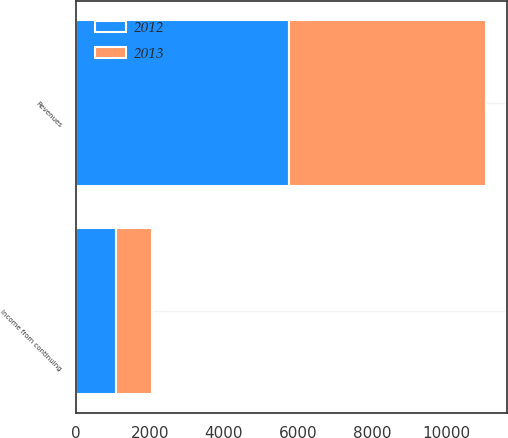Convert chart. <chart><loc_0><loc_0><loc_500><loc_500><stacked_bar_chart><ecel><fcel>Revenues<fcel>Income from continuing<nl><fcel>2012<fcel>5755<fcel>1080<nl><fcel>2013<fcel>5315<fcel>992<nl></chart> 